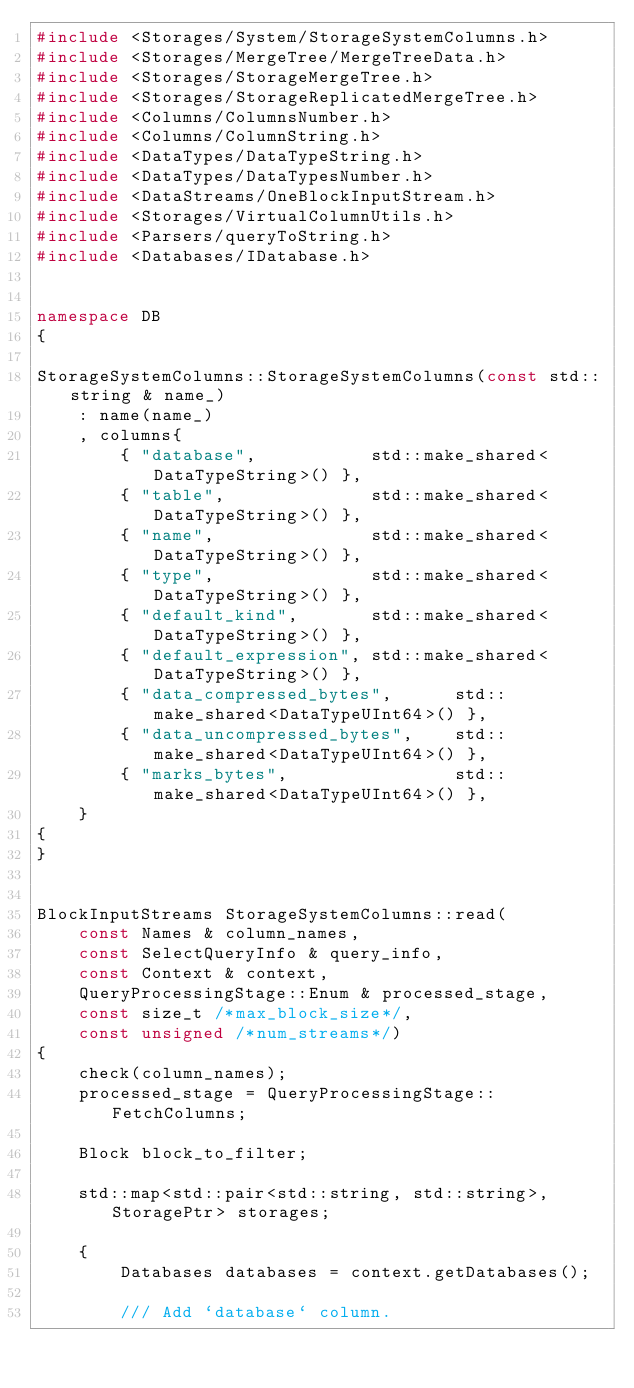<code> <loc_0><loc_0><loc_500><loc_500><_C++_>#include <Storages/System/StorageSystemColumns.h>
#include <Storages/MergeTree/MergeTreeData.h>
#include <Storages/StorageMergeTree.h>
#include <Storages/StorageReplicatedMergeTree.h>
#include <Columns/ColumnsNumber.h>
#include <Columns/ColumnString.h>
#include <DataTypes/DataTypeString.h>
#include <DataTypes/DataTypesNumber.h>
#include <DataStreams/OneBlockInputStream.h>
#include <Storages/VirtualColumnUtils.h>
#include <Parsers/queryToString.h>
#include <Databases/IDatabase.h>


namespace DB
{

StorageSystemColumns::StorageSystemColumns(const std::string & name_)
    : name(name_)
    , columns{
        { "database",           std::make_shared<DataTypeString>() },
        { "table",              std::make_shared<DataTypeString>() },
        { "name",               std::make_shared<DataTypeString>() },
        { "type",               std::make_shared<DataTypeString>() },
        { "default_kind",       std::make_shared<DataTypeString>() },
        { "default_expression", std::make_shared<DataTypeString>() },
        { "data_compressed_bytes",      std::make_shared<DataTypeUInt64>() },
        { "data_uncompressed_bytes",    std::make_shared<DataTypeUInt64>() },
        { "marks_bytes",                std::make_shared<DataTypeUInt64>() },
    }
{
}


BlockInputStreams StorageSystemColumns::read(
    const Names & column_names,
    const SelectQueryInfo & query_info,
    const Context & context,
    QueryProcessingStage::Enum & processed_stage,
    const size_t /*max_block_size*/,
    const unsigned /*num_streams*/)
{
    check(column_names);
    processed_stage = QueryProcessingStage::FetchColumns;

    Block block_to_filter;

    std::map<std::pair<std::string, std::string>, StoragePtr> storages;

    {
        Databases databases = context.getDatabases();

        /// Add `database` column.</code> 